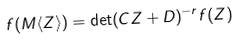<formula> <loc_0><loc_0><loc_500><loc_500>f ( M \langle Z \rangle ) = \det ( C Z + D ) ^ { - r } f ( Z )</formula> 